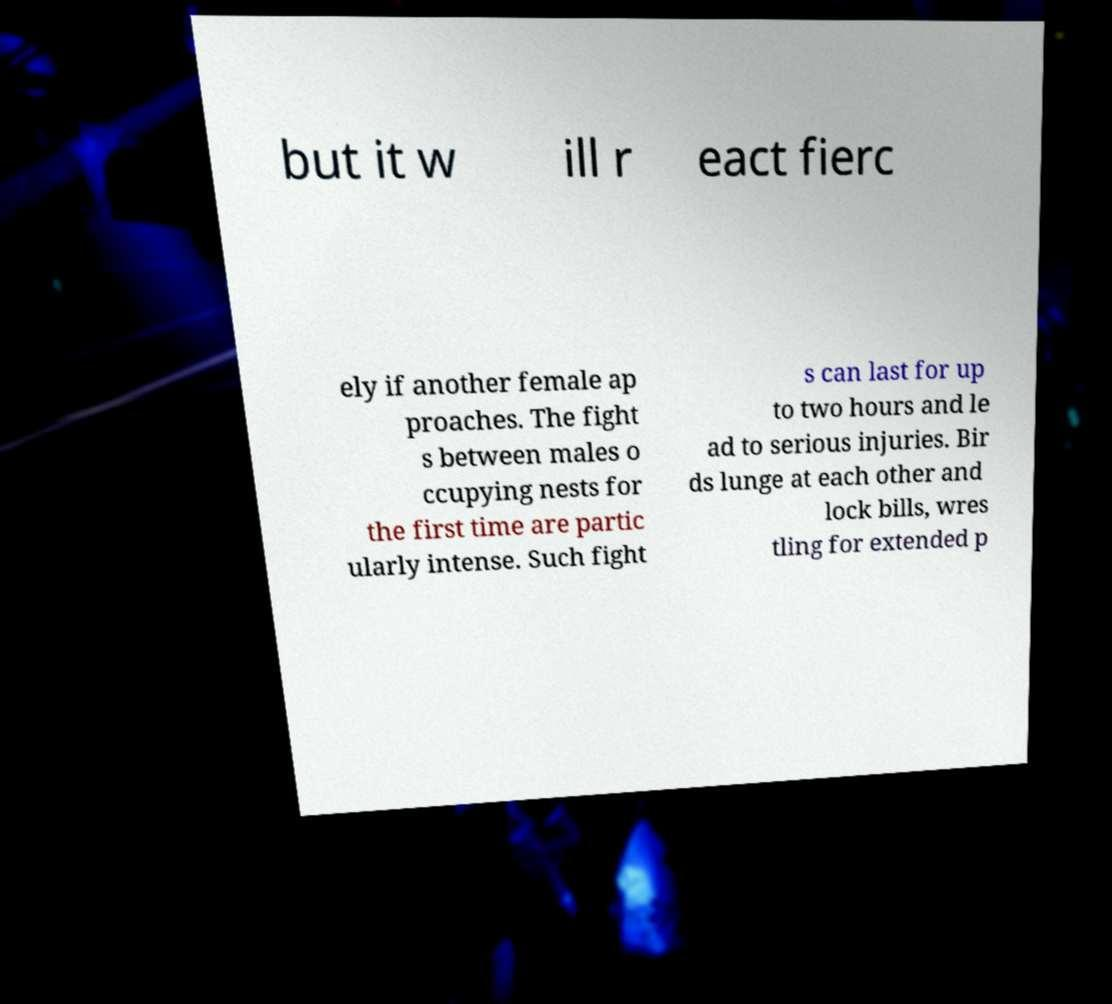Can you read and provide the text displayed in the image?This photo seems to have some interesting text. Can you extract and type it out for me? but it w ill r eact fierc ely if another female ap proaches. The fight s between males o ccupying nests for the first time are partic ularly intense. Such fight s can last for up to two hours and le ad to serious injuries. Bir ds lunge at each other and lock bills, wres tling for extended p 